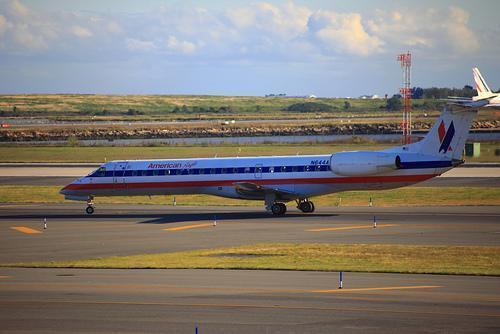How many planes are visible?
Give a very brief answer. 2. 